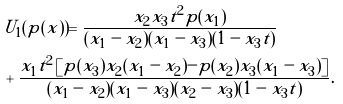<formula> <loc_0><loc_0><loc_500><loc_500>& U _ { 1 } ( p ( x ) ) = \frac { x _ { 2 } x _ { 3 } t ^ { 2 } p ( x _ { 1 } ) } { ( x _ { 1 } - x _ { 2 } ) ( x _ { 1 } - x _ { 3 } ) ( 1 - x _ { 3 } t ) } \\ & + \frac { x _ { 1 } t ^ { 2 } \left [ p ( x _ { 3 } ) x _ { 2 } ( x _ { 1 } - x _ { 2 } ) - p ( x _ { 2 } ) x _ { 3 } ( x _ { 1 } - x _ { 3 } ) \right ] } { ( x _ { 1 } - x _ { 2 } ) ( x _ { 1 } - x _ { 3 } ) ( x _ { 2 } - x _ { 3 } ) ( 1 - x _ { 3 } t ) } .</formula> 